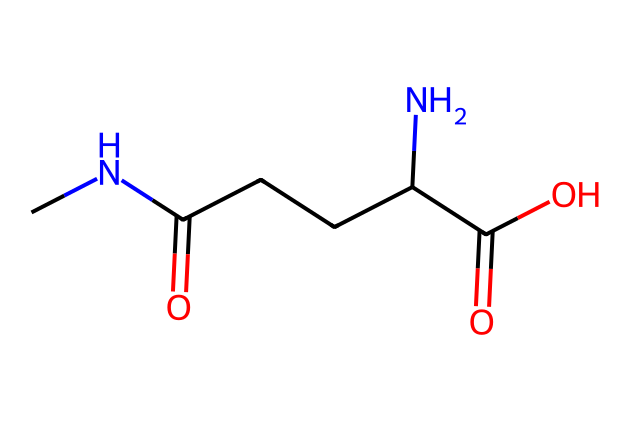What is the molecular formula of theanine derived from its structure? By analyzing the SMILES representation, we can identify the constituent atoms: carbon (C), hydrogen (H), nitrogen (N), and oxygen (O). Counting the atoms represented gives us a molecular formula of C₇H₁₄N₂O₄.
Answer: C7H14N2O4 How many carbon atoms are present in theanine? The SMILES representation indicates the number of carbon (C) atoms explicitly. By counting them from the structure, we find there are 7 carbon atoms.
Answer: 7 What functional groups are present in theanine? Examination of the SMILES structure shows the presence of carbonyl (C=O), amine (–NH), and carboxylic acid (–COOH) groups. Each of these groups contributes to the properties of theanine.
Answer: carbonyl, amine, carboxylic acid Is theanine a primary or secondary amine? The structure reveals the nitrogen atoms and how they are bonded. Since one nitrogen atom is connected to two carbons and one is attached to one carbon and one hydrogen, it confirms that theanine contains a secondary amine.
Answer: secondary What type of chemical is theanine primarily categorized as? Based on its structure, theanine primarily consists of amino acids, which are characterized by the presence of an amino group and a carboxylic acid. The combination within its structure confirms it as an amino acid.
Answer: amino acid Does theanine contain any aromatic rings in its structure? Analyzing the SMILES, we can see that the compound does not have any carbon atoms connected in a way that forms a closed aromatic ring, which would indicate aromaticity. Thus, theanine does not contain an aromatic ring.
Answer: no 